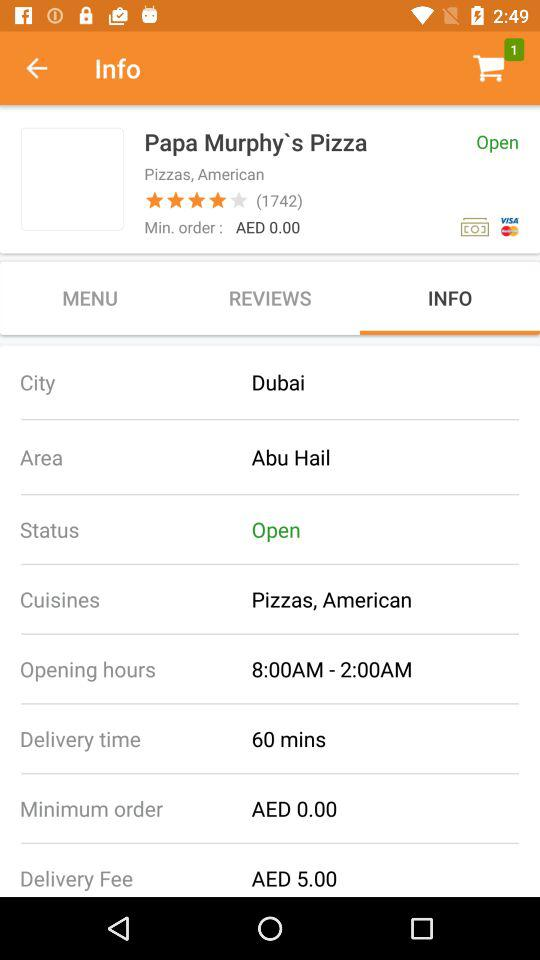How many items are in the cart? There is one item in the cart. 